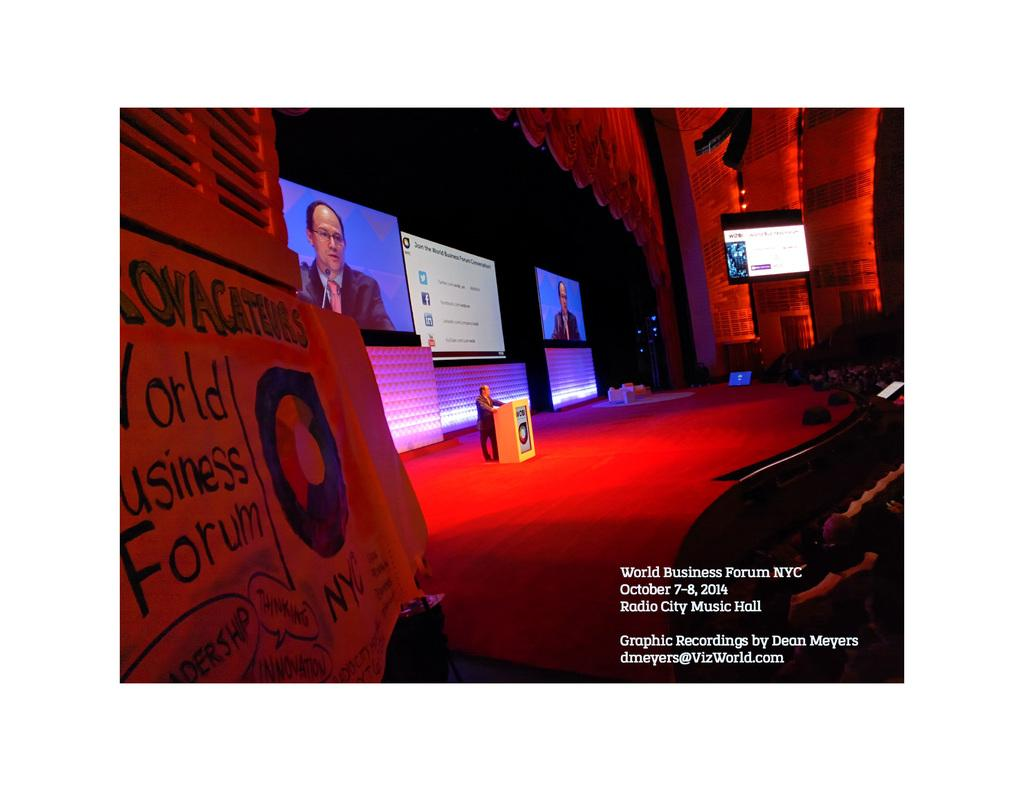Where was the image taken? The image was taken in an auditorium. What can be seen on the left side of the image? There is a banner on the left side of the image. What is the main feature of the auditorium? There is a stage in the image. What is located on the stage? There is a podium in the image. Who is present in the image? There is a man in the image. What is used for displaying information or visuals in the auditorium? There are screens in the image. What type of lighting is present in the image? There is a red light in the image. What type of comb is the man using in the image? There is no comb present in the image. What type of potato is being served on the stage in the image? There is no potato present in the image. What type of badge is the man wearing in the image? There is no badge visible on the man in the image. 